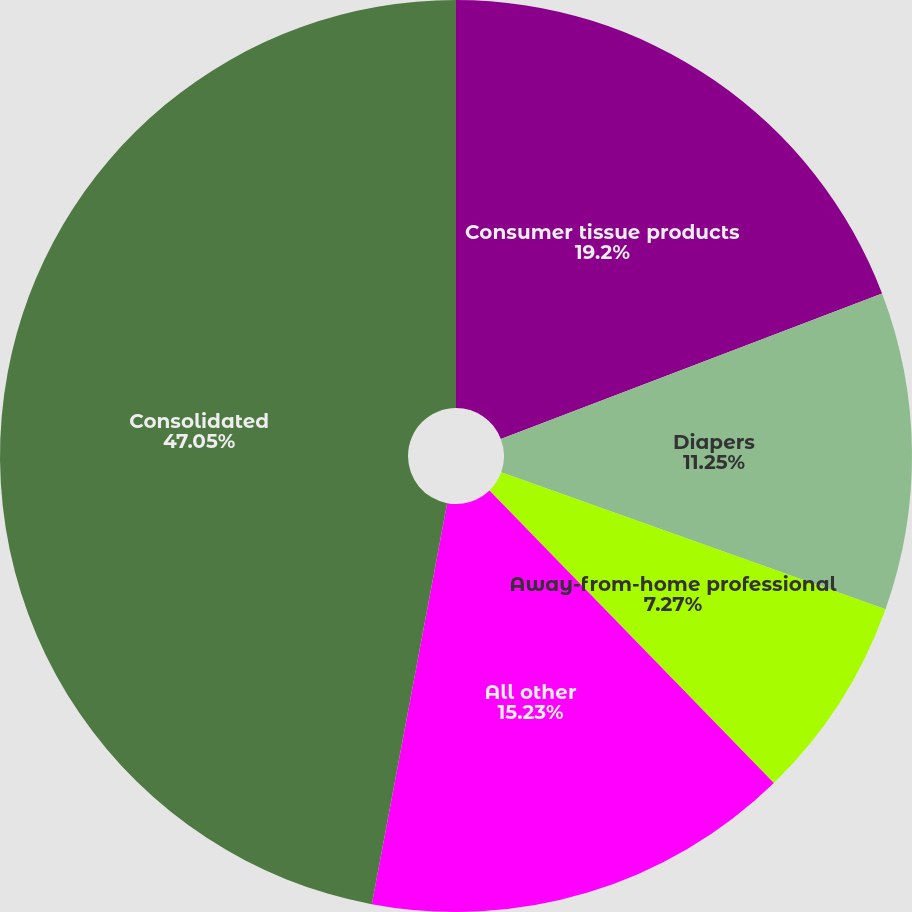<chart> <loc_0><loc_0><loc_500><loc_500><pie_chart><fcel>Consumer tissue products<fcel>Diapers<fcel>Away-from-home professional<fcel>All other<fcel>Consolidated<nl><fcel>19.2%<fcel>11.25%<fcel>7.27%<fcel>15.23%<fcel>47.04%<nl></chart> 